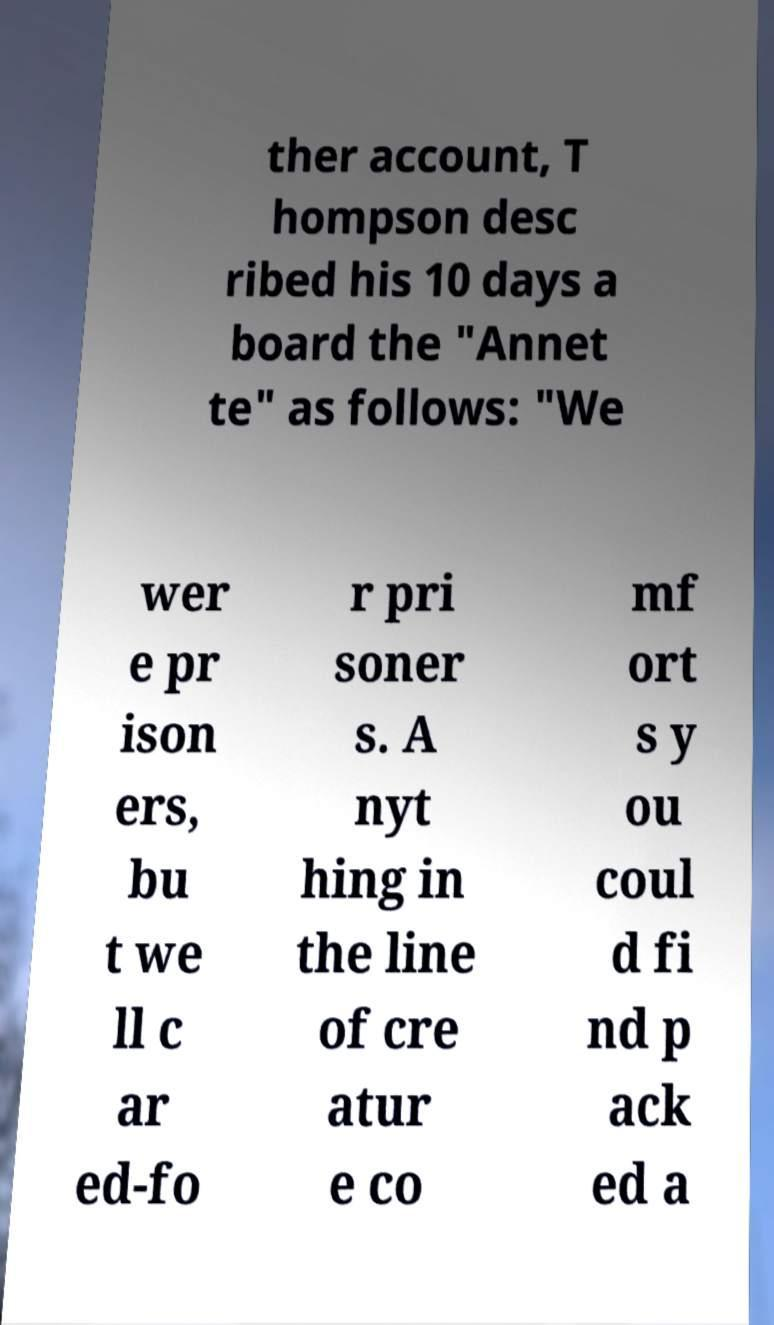For documentation purposes, I need the text within this image transcribed. Could you provide that? ther account, T hompson desc ribed his 10 days a board the "Annet te" as follows: "We wer e pr ison ers, bu t we ll c ar ed-fo r pri soner s. A nyt hing in the line of cre atur e co mf ort s y ou coul d fi nd p ack ed a 